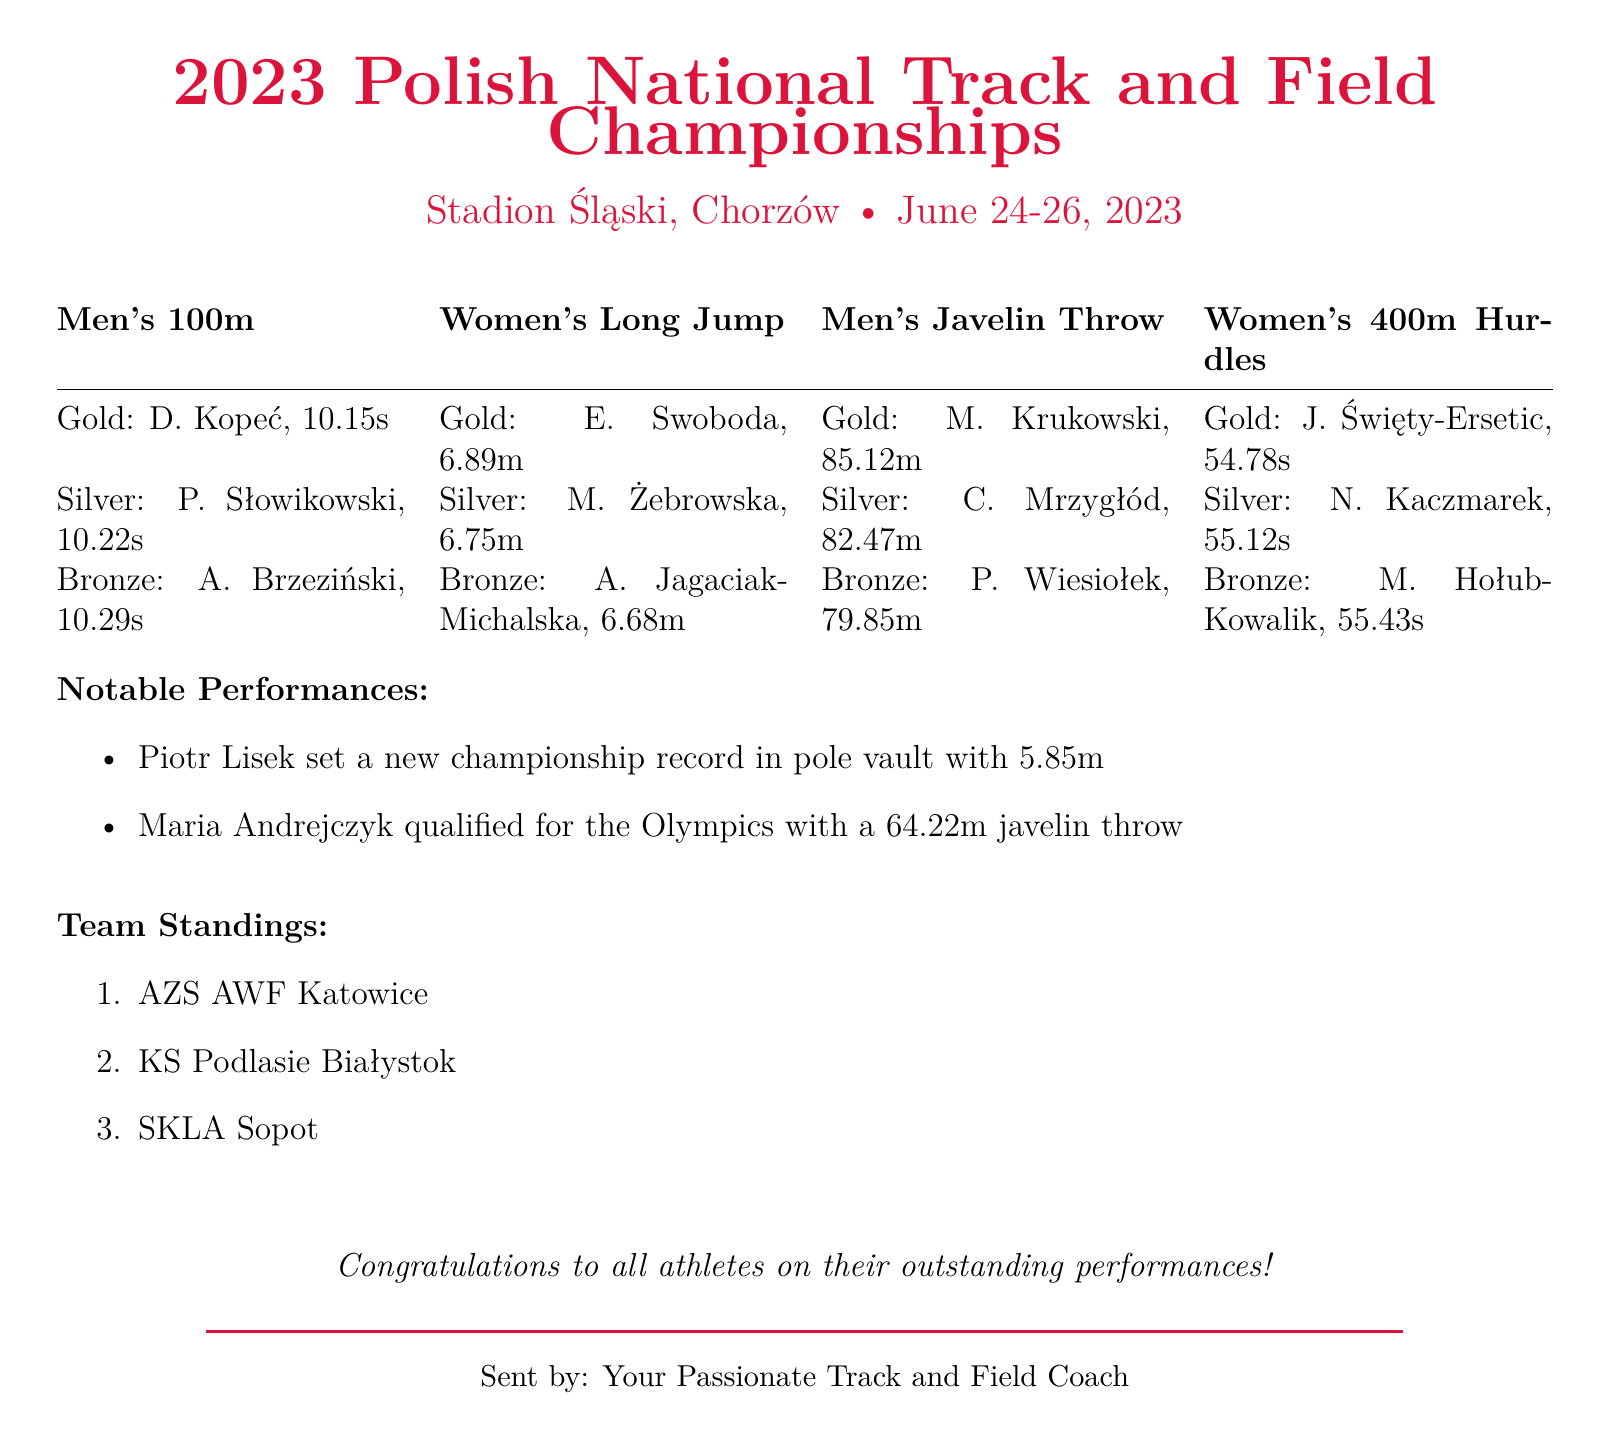What date did the championship take place? The championship took place from June 24-26, 2023, as mentioned at the beginning of the document.
Answer: June 24-26, 2023 Who won the gold medal in the Men's 100m event? The gold medal winner in the Men's 100m event is D. Kopeć, as listed in the performance results.
Answer: D. Kopeć What is the distance of the Women's Long Jump gold medal? The distance of the Women's Long Jump gold medal is provided as 6.89m in the results section.
Answer: 6.89m Which team ranked first in the standings? The first-place team is mentioned in the Team Standings section, which states AZS AWF Katowice as the top team.
Answer: AZS AWF Katowice How far did Maria Andrejczyk throw the javelin? The document states Maria Andrejczyk qualified for the Olympics with a throw of 64.22m, which provides her throw distance.
Answer: 64.22m What notable record was set during the championship? The document specifies that Piotr Lisek set a new championship record in pole vault with 5.85m, highlighting a notable performance.
Answer: 5.85m How many medals did A. Brzeziński win in the Men's 100m event? The results indicate that A. Brzeziński won the bronze medal in the Men's 100m event, making the total count of medals he won in this event one.
Answer: One What is the color of the document's border? The document's border is styled with the color polishred, which is indicated throughout its style definitions.
Answer: Polish red 